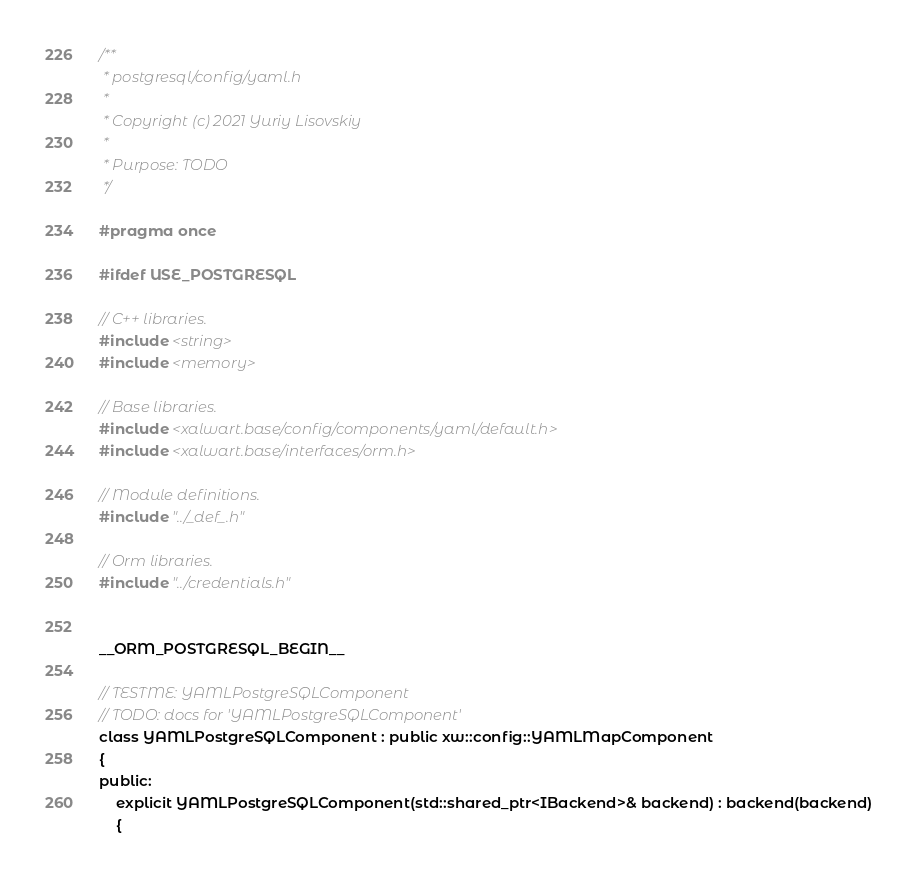<code> <loc_0><loc_0><loc_500><loc_500><_C_>/**
 * postgresql/config/yaml.h
 *
 * Copyright (c) 2021 Yuriy Lisovskiy
 *
 * Purpose: TODO
 */

#pragma once

#ifdef USE_POSTGRESQL

// C++ libraries.
#include <string>
#include <memory>

// Base libraries.
#include <xalwart.base/config/components/yaml/default.h>
#include <xalwart.base/interfaces/orm.h>

// Module definitions.
#include "../_def_.h"

// Orm libraries.
#include "../credentials.h"


__ORM_POSTGRESQL_BEGIN__

// TESTME: YAMLPostgreSQLComponent
// TODO: docs for 'YAMLPostgreSQLComponent'
class YAMLPostgreSQLComponent : public xw::config::YAMLMapComponent
{
public:
	explicit YAMLPostgreSQLComponent(std::shared_ptr<IBackend>& backend) : backend(backend)
	{</code> 